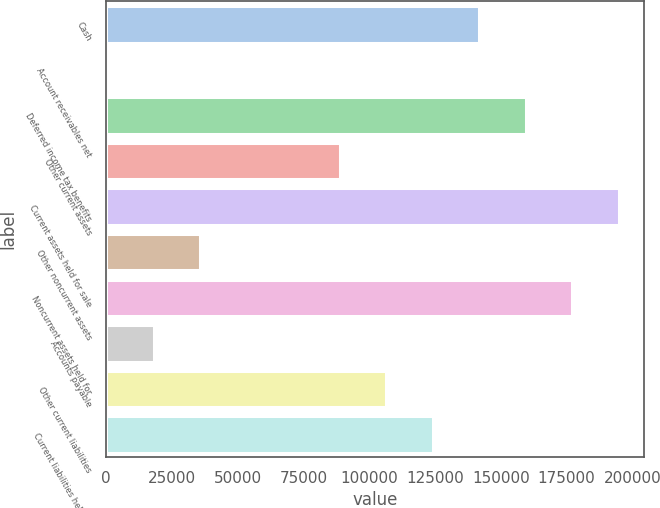Convert chart to OTSL. <chart><loc_0><loc_0><loc_500><loc_500><bar_chart><fcel>Cash<fcel>Account receivables net<fcel>Deferred income tax benefits<fcel>Other current assets<fcel>Current assets held for sale<fcel>Other noncurrent assets<fcel>Noncurrent assets held for<fcel>Accounts payable<fcel>Other current liabilities<fcel>Current liabilities held for<nl><fcel>141716<fcel>421<fcel>159378<fcel>88730.5<fcel>194702<fcel>35744.8<fcel>177040<fcel>18082.9<fcel>106392<fcel>124054<nl></chart> 